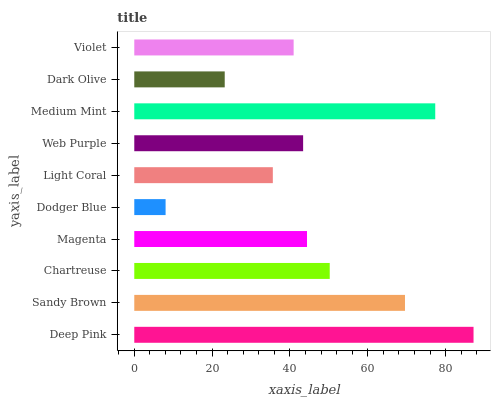Is Dodger Blue the minimum?
Answer yes or no. Yes. Is Deep Pink the maximum?
Answer yes or no. Yes. Is Sandy Brown the minimum?
Answer yes or no. No. Is Sandy Brown the maximum?
Answer yes or no. No. Is Deep Pink greater than Sandy Brown?
Answer yes or no. Yes. Is Sandy Brown less than Deep Pink?
Answer yes or no. Yes. Is Sandy Brown greater than Deep Pink?
Answer yes or no. No. Is Deep Pink less than Sandy Brown?
Answer yes or no. No. Is Magenta the high median?
Answer yes or no. Yes. Is Web Purple the low median?
Answer yes or no. Yes. Is Violet the high median?
Answer yes or no. No. Is Medium Mint the low median?
Answer yes or no. No. 